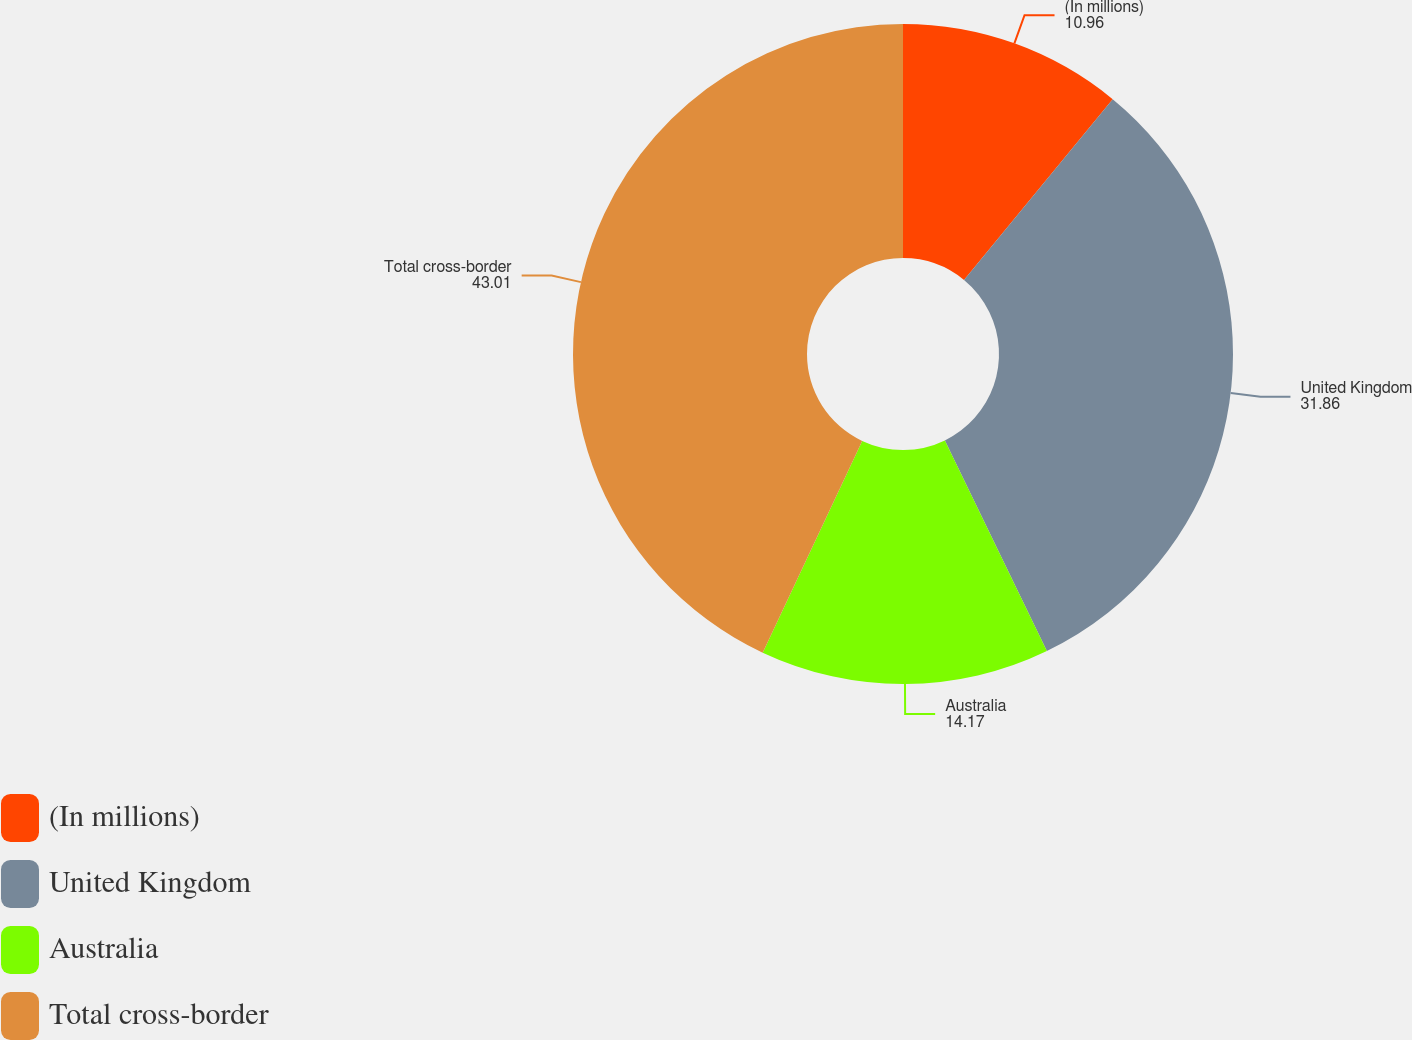<chart> <loc_0><loc_0><loc_500><loc_500><pie_chart><fcel>(In millions)<fcel>United Kingdom<fcel>Australia<fcel>Total cross-border<nl><fcel>10.96%<fcel>31.86%<fcel>14.17%<fcel>43.01%<nl></chart> 